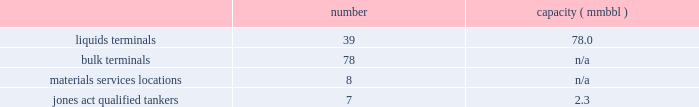In direct competition with other co2 pipelines .
We also compete with other interest owners in the mcelmo dome unit and the bravo dome unit for transportation of co2 to the denver city , texas market area .
Terminals our terminals segment includes the operations of our petroleum , chemical , ethanol and other liquids terminal facilities ( other than those included in the products pipelines segment ) and all of our coal , petroleum coke , fertilizer , steel , ores and other dry-bulk material services facilities , including all transload , engineering , conveying and other in-plant services .
Our terminals are located throughout the u.s .
And in portions of canada .
We believe the location of our facilities and our ability to provide flexibility to customers help attract new and retain existing customers at our terminals and provide us opportunities for expansion .
We often classify our terminal operations based on the handling of either liquids or dry-bulk material products .
In addition , we have jones act qualified product tankers that provide marine transportation of crude oil , condensate and refined products in the u.s .
The following summarizes our terminals segment assets , as of december 31 , 2014 : number capacity ( mmbbl ) .
Competition we are one of the largest independent operators of liquids terminals in the u.s , based on barrels of liquids terminaling capacity .
Our liquids terminals compete with other publicly or privately held independent liquids terminals , and terminals owned by oil , chemical and pipeline companies .
Our bulk terminals compete with numerous independent terminal operators , terminals owned by producers and distributors of bulk commodities , stevedoring companies and other industrial companies opting not to outsource terminal services .
In some locations , competitors are smaller , independent operators with lower cost structures .
Our rail transloading ( material services ) operations compete with a variety of single- or multi-site transload , warehouse and terminal operators across the u.s .
Our jones act qualified product tankers compete with other jones act qualified vessel fleets .
Table of contents .
What is the average capacity per jones act qualified tanker in mmbbl? 
Computations: (2.3 / 7)
Answer: 0.32857. 